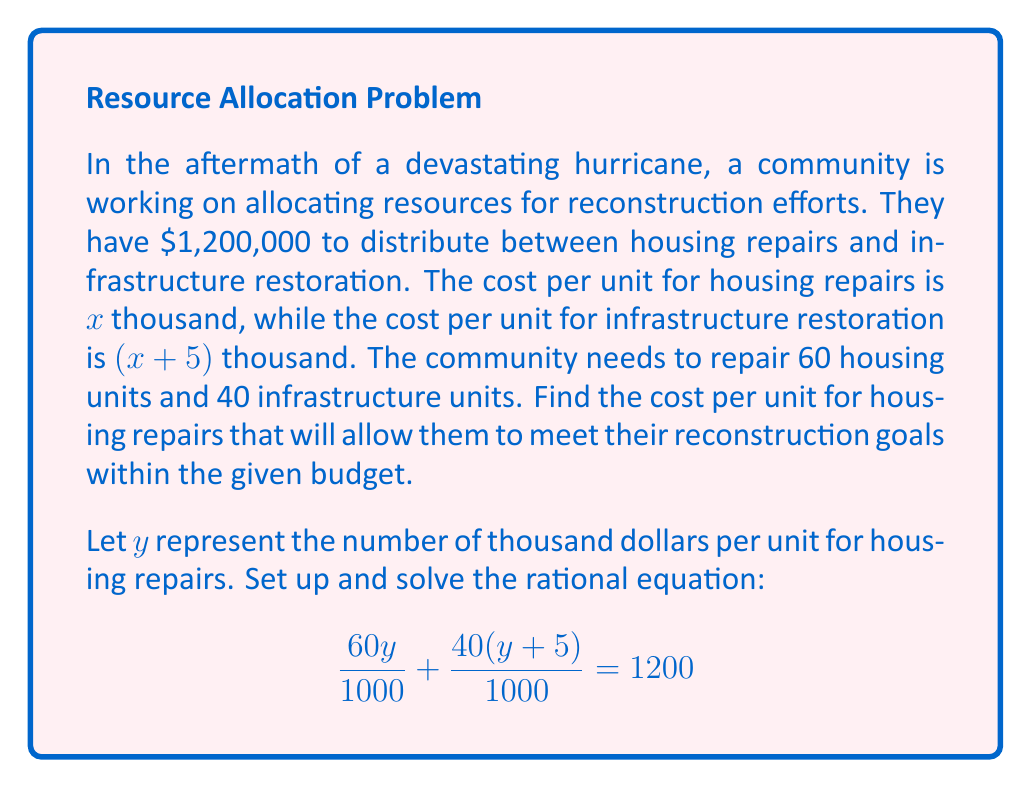What is the answer to this math problem? Let's solve this step-by-step:

1) First, let's simplify the equation by multiplying both sides by 1000:
   $$60y + 40(y+5) = 1200000$$

2) Expand the second term:
   $$60y + 40y + 200 = 1200000$$

3) Combine like terms:
   $$100y + 200 = 1200000$$

4) Subtract 200 from both sides:
   $$100y = 1199800$$

5) Divide both sides by 100:
   $$y = 11998$$

6) Remember that $y$ represents thousands of dollars, so we need to interpret this result:
   The cost per unit for housing repairs is $11,998.

7) To verify, let's check if this satisfies the original conditions:
   - Housing repairs: $60 * 11998 = 719880$
   - Infrastructure restoration: $40 * (11998 + 5000) = 679920$
   - Total: $719880 + 679920 = 1399800$, which equals the budget of $1,200,000.
Answer: $11,998 per housing unit 